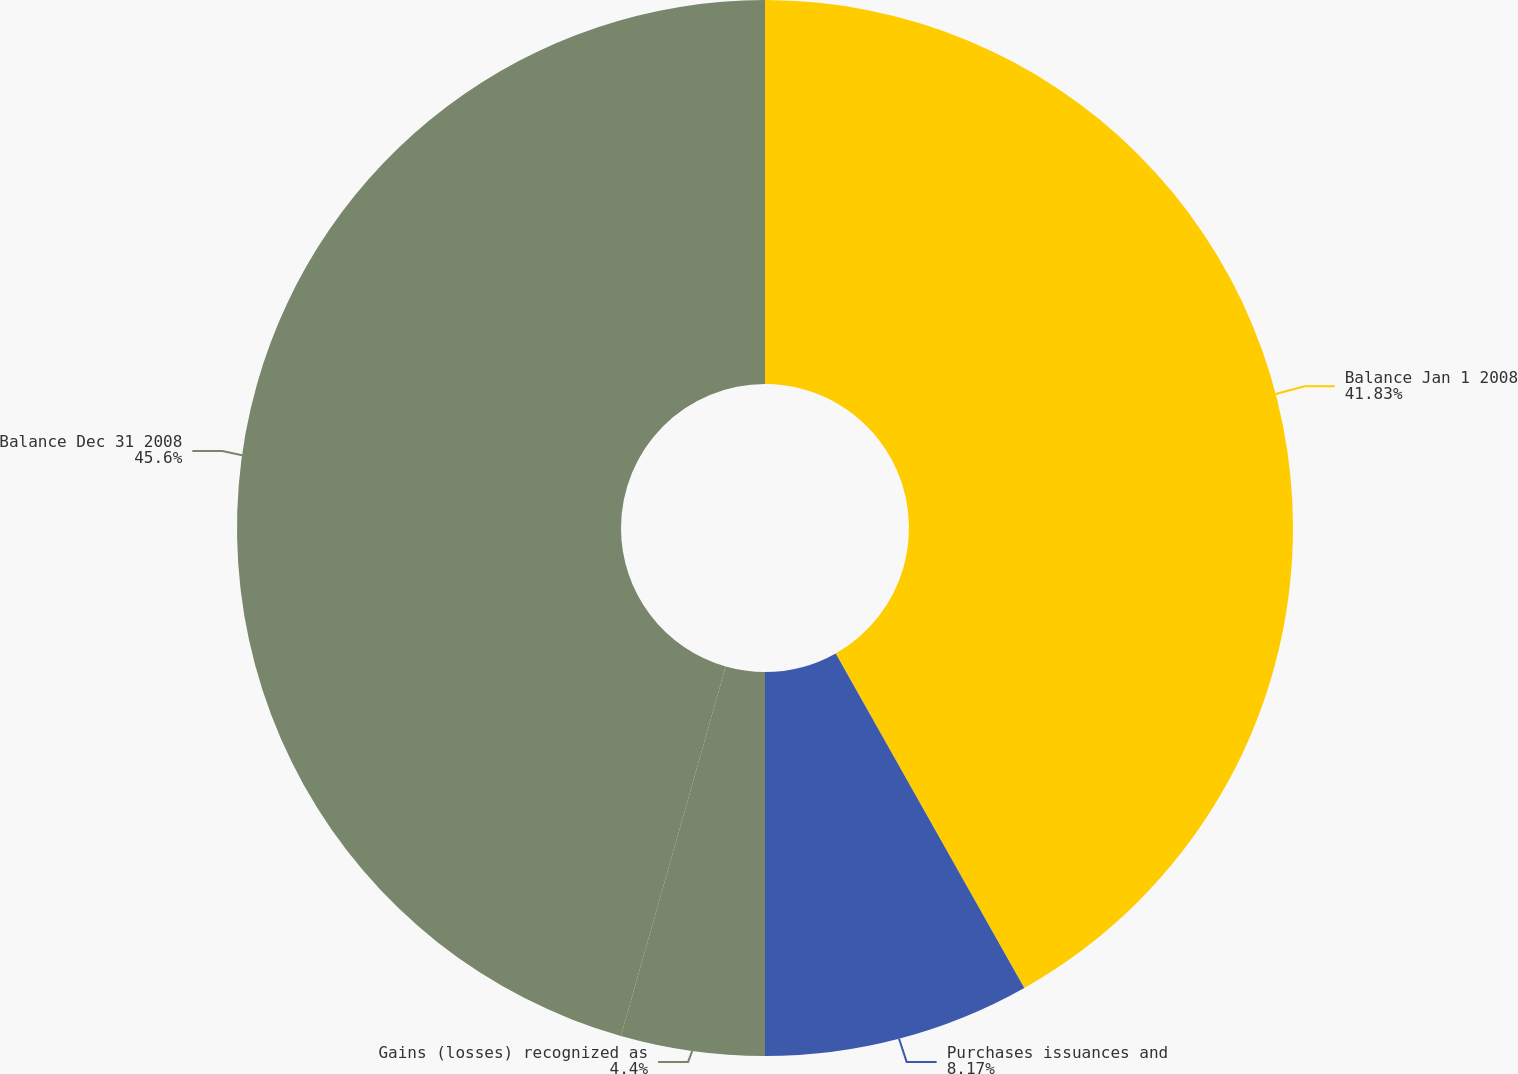Convert chart. <chart><loc_0><loc_0><loc_500><loc_500><pie_chart><fcel>Balance Jan 1 2008<fcel>Purchases issuances and<fcel>Gains (losses) recognized as<fcel>Balance Dec 31 2008<nl><fcel>41.83%<fcel>8.17%<fcel>4.4%<fcel>45.6%<nl></chart> 